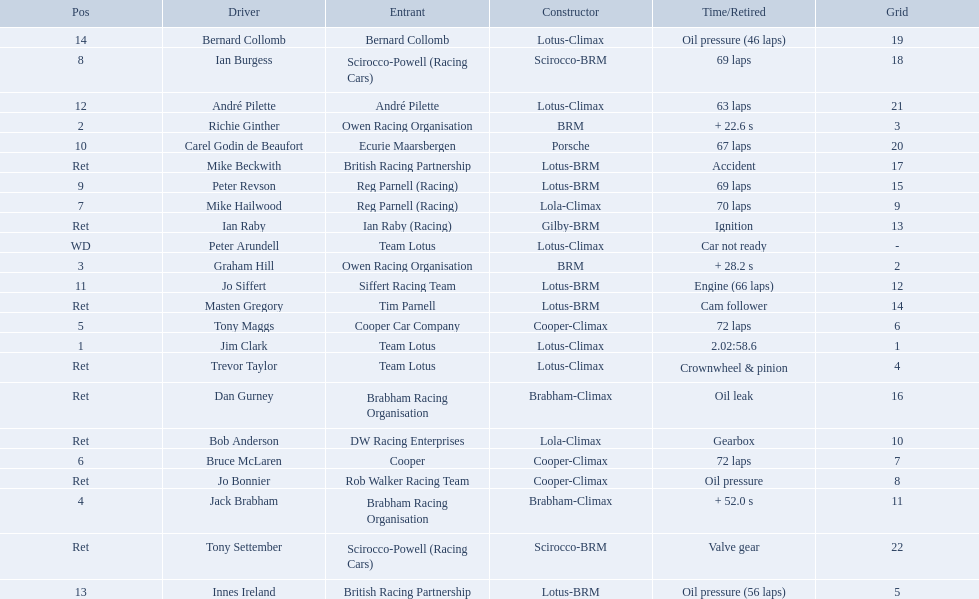Who were the drivers in the the 1963 international gold cup? Jim Clark, Richie Ginther, Graham Hill, Jack Brabham, Tony Maggs, Bruce McLaren, Mike Hailwood, Ian Burgess, Peter Revson, Carel Godin de Beaufort, Jo Siffert, André Pilette, Innes Ireland, Bernard Collomb, Ian Raby, Dan Gurney, Mike Beckwith, Masten Gregory, Trevor Taylor, Jo Bonnier, Tony Settember, Bob Anderson, Peter Arundell. Which drivers drove a cooper-climax car? Tony Maggs, Bruce McLaren, Jo Bonnier. What did these drivers place? 5, 6, Ret. What was the best placing position? 5. Who was the driver with this placing? Tony Maggs. 